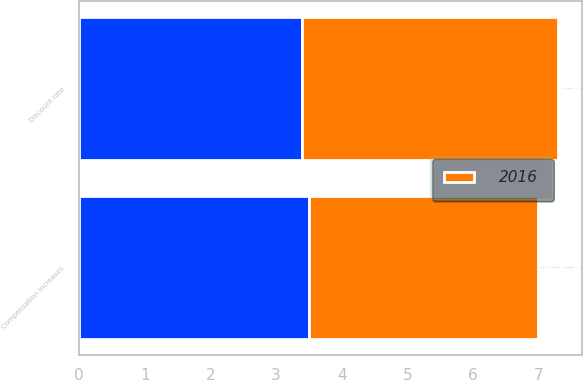Convert chart. <chart><loc_0><loc_0><loc_500><loc_500><stacked_bar_chart><ecel><fcel>Discount rate<fcel>Compensation increases<nl><fcel>nan<fcel>3.4<fcel>3.5<nl><fcel>2016<fcel>3.9<fcel>3.5<nl></chart> 